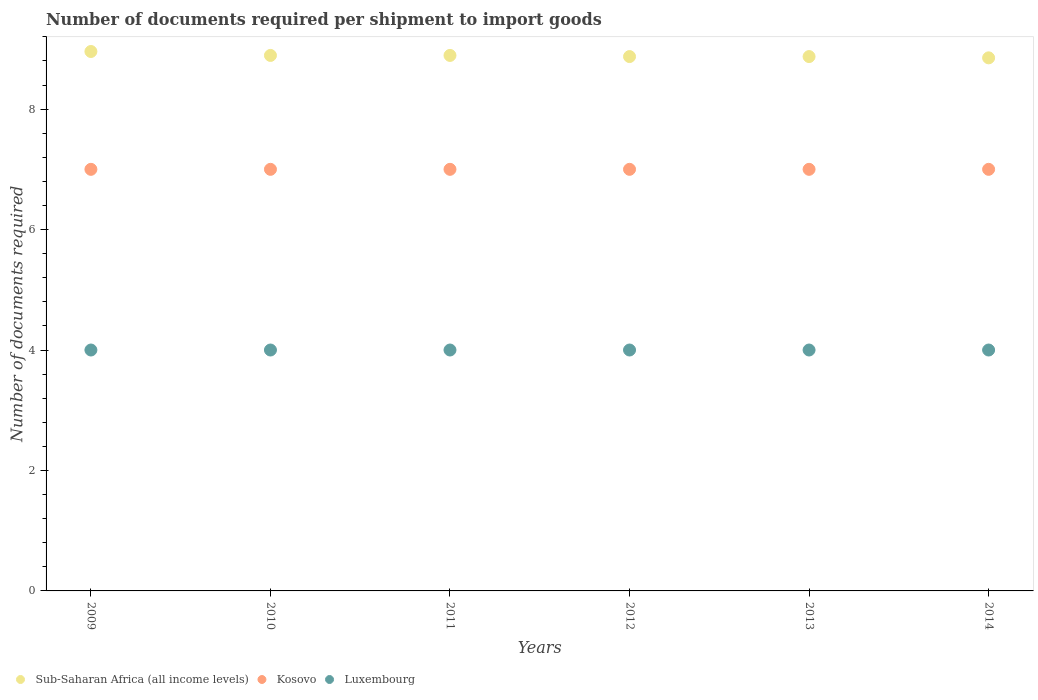How many different coloured dotlines are there?
Your answer should be compact. 3. Across all years, what is the maximum number of documents required per shipment to import goods in Kosovo?
Offer a terse response. 7. Across all years, what is the minimum number of documents required per shipment to import goods in Sub-Saharan Africa (all income levels)?
Ensure brevity in your answer.  8.85. What is the total number of documents required per shipment to import goods in Sub-Saharan Africa (all income levels) in the graph?
Ensure brevity in your answer.  53.33. What is the difference between the number of documents required per shipment to import goods in Luxembourg in 2010 and the number of documents required per shipment to import goods in Kosovo in 2012?
Make the answer very short. -3. What is the average number of documents required per shipment to import goods in Luxembourg per year?
Provide a short and direct response. 4. In the year 2009, what is the difference between the number of documents required per shipment to import goods in Kosovo and number of documents required per shipment to import goods in Sub-Saharan Africa (all income levels)?
Your answer should be compact. -1.96. In how many years, is the number of documents required per shipment to import goods in Kosovo greater than 6.4?
Provide a short and direct response. 6. What is the ratio of the number of documents required per shipment to import goods in Luxembourg in 2013 to that in 2014?
Ensure brevity in your answer.  1. Is the number of documents required per shipment to import goods in Kosovo in 2010 less than that in 2014?
Your response must be concise. No. Is the number of documents required per shipment to import goods in Sub-Saharan Africa (all income levels) strictly less than the number of documents required per shipment to import goods in Kosovo over the years?
Give a very brief answer. No. What is the difference between two consecutive major ticks on the Y-axis?
Offer a very short reply. 2. Are the values on the major ticks of Y-axis written in scientific E-notation?
Keep it short and to the point. No. Does the graph contain grids?
Give a very brief answer. No. How are the legend labels stacked?
Keep it short and to the point. Horizontal. What is the title of the graph?
Your answer should be compact. Number of documents required per shipment to import goods. What is the label or title of the X-axis?
Provide a succinct answer. Years. What is the label or title of the Y-axis?
Provide a succinct answer. Number of documents required. What is the Number of documents required in Sub-Saharan Africa (all income levels) in 2009?
Ensure brevity in your answer.  8.96. What is the Number of documents required in Kosovo in 2009?
Offer a terse response. 7. What is the Number of documents required in Luxembourg in 2009?
Provide a short and direct response. 4. What is the Number of documents required of Sub-Saharan Africa (all income levels) in 2010?
Your response must be concise. 8.89. What is the Number of documents required of Kosovo in 2010?
Your response must be concise. 7. What is the Number of documents required in Luxembourg in 2010?
Your answer should be compact. 4. What is the Number of documents required of Sub-Saharan Africa (all income levels) in 2011?
Offer a terse response. 8.89. What is the Number of documents required of Luxembourg in 2011?
Your response must be concise. 4. What is the Number of documents required in Sub-Saharan Africa (all income levels) in 2012?
Offer a very short reply. 8.87. What is the Number of documents required of Kosovo in 2012?
Offer a very short reply. 7. What is the Number of documents required in Sub-Saharan Africa (all income levels) in 2013?
Your answer should be very brief. 8.87. What is the Number of documents required in Luxembourg in 2013?
Keep it short and to the point. 4. What is the Number of documents required in Sub-Saharan Africa (all income levels) in 2014?
Offer a terse response. 8.85. What is the Number of documents required in Luxembourg in 2014?
Your answer should be very brief. 4. Across all years, what is the maximum Number of documents required in Sub-Saharan Africa (all income levels)?
Ensure brevity in your answer.  8.96. Across all years, what is the maximum Number of documents required of Kosovo?
Give a very brief answer. 7. Across all years, what is the minimum Number of documents required of Sub-Saharan Africa (all income levels)?
Your answer should be very brief. 8.85. Across all years, what is the minimum Number of documents required in Luxembourg?
Give a very brief answer. 4. What is the total Number of documents required of Sub-Saharan Africa (all income levels) in the graph?
Keep it short and to the point. 53.33. What is the difference between the Number of documents required of Sub-Saharan Africa (all income levels) in 2009 and that in 2010?
Offer a very short reply. 0.07. What is the difference between the Number of documents required in Kosovo in 2009 and that in 2010?
Make the answer very short. 0. What is the difference between the Number of documents required of Sub-Saharan Africa (all income levels) in 2009 and that in 2011?
Your answer should be very brief. 0.07. What is the difference between the Number of documents required of Sub-Saharan Africa (all income levels) in 2009 and that in 2012?
Offer a very short reply. 0.08. What is the difference between the Number of documents required in Luxembourg in 2009 and that in 2012?
Offer a very short reply. 0. What is the difference between the Number of documents required in Sub-Saharan Africa (all income levels) in 2009 and that in 2013?
Offer a terse response. 0.08. What is the difference between the Number of documents required of Sub-Saharan Africa (all income levels) in 2009 and that in 2014?
Make the answer very short. 0.11. What is the difference between the Number of documents required in Luxembourg in 2009 and that in 2014?
Provide a short and direct response. 0. What is the difference between the Number of documents required of Sub-Saharan Africa (all income levels) in 2010 and that in 2011?
Your answer should be very brief. 0. What is the difference between the Number of documents required in Luxembourg in 2010 and that in 2011?
Your response must be concise. 0. What is the difference between the Number of documents required of Sub-Saharan Africa (all income levels) in 2010 and that in 2012?
Make the answer very short. 0.02. What is the difference between the Number of documents required in Kosovo in 2010 and that in 2012?
Your answer should be compact. 0. What is the difference between the Number of documents required of Luxembourg in 2010 and that in 2012?
Provide a short and direct response. 0. What is the difference between the Number of documents required of Sub-Saharan Africa (all income levels) in 2010 and that in 2013?
Offer a very short reply. 0.02. What is the difference between the Number of documents required of Luxembourg in 2010 and that in 2013?
Provide a succinct answer. 0. What is the difference between the Number of documents required of Sub-Saharan Africa (all income levels) in 2010 and that in 2014?
Offer a terse response. 0.04. What is the difference between the Number of documents required in Sub-Saharan Africa (all income levels) in 2011 and that in 2012?
Give a very brief answer. 0.02. What is the difference between the Number of documents required of Kosovo in 2011 and that in 2012?
Provide a short and direct response. 0. What is the difference between the Number of documents required of Luxembourg in 2011 and that in 2012?
Make the answer very short. 0. What is the difference between the Number of documents required of Sub-Saharan Africa (all income levels) in 2011 and that in 2013?
Your response must be concise. 0.02. What is the difference between the Number of documents required in Kosovo in 2011 and that in 2013?
Offer a terse response. 0. What is the difference between the Number of documents required of Luxembourg in 2011 and that in 2013?
Keep it short and to the point. 0. What is the difference between the Number of documents required in Sub-Saharan Africa (all income levels) in 2011 and that in 2014?
Your response must be concise. 0.04. What is the difference between the Number of documents required of Kosovo in 2011 and that in 2014?
Offer a very short reply. 0. What is the difference between the Number of documents required of Kosovo in 2012 and that in 2013?
Keep it short and to the point. 0. What is the difference between the Number of documents required in Sub-Saharan Africa (all income levels) in 2012 and that in 2014?
Provide a short and direct response. 0.02. What is the difference between the Number of documents required of Luxembourg in 2012 and that in 2014?
Give a very brief answer. 0. What is the difference between the Number of documents required of Sub-Saharan Africa (all income levels) in 2013 and that in 2014?
Provide a short and direct response. 0.02. What is the difference between the Number of documents required in Luxembourg in 2013 and that in 2014?
Provide a succinct answer. 0. What is the difference between the Number of documents required of Sub-Saharan Africa (all income levels) in 2009 and the Number of documents required of Kosovo in 2010?
Give a very brief answer. 1.96. What is the difference between the Number of documents required of Sub-Saharan Africa (all income levels) in 2009 and the Number of documents required of Luxembourg in 2010?
Your answer should be very brief. 4.96. What is the difference between the Number of documents required of Kosovo in 2009 and the Number of documents required of Luxembourg in 2010?
Give a very brief answer. 3. What is the difference between the Number of documents required of Sub-Saharan Africa (all income levels) in 2009 and the Number of documents required of Kosovo in 2011?
Your response must be concise. 1.96. What is the difference between the Number of documents required of Sub-Saharan Africa (all income levels) in 2009 and the Number of documents required of Luxembourg in 2011?
Offer a terse response. 4.96. What is the difference between the Number of documents required of Sub-Saharan Africa (all income levels) in 2009 and the Number of documents required of Kosovo in 2012?
Your answer should be very brief. 1.96. What is the difference between the Number of documents required of Sub-Saharan Africa (all income levels) in 2009 and the Number of documents required of Luxembourg in 2012?
Provide a short and direct response. 4.96. What is the difference between the Number of documents required in Sub-Saharan Africa (all income levels) in 2009 and the Number of documents required in Kosovo in 2013?
Offer a very short reply. 1.96. What is the difference between the Number of documents required in Sub-Saharan Africa (all income levels) in 2009 and the Number of documents required in Luxembourg in 2013?
Provide a short and direct response. 4.96. What is the difference between the Number of documents required in Kosovo in 2009 and the Number of documents required in Luxembourg in 2013?
Your answer should be compact. 3. What is the difference between the Number of documents required in Sub-Saharan Africa (all income levels) in 2009 and the Number of documents required in Kosovo in 2014?
Provide a short and direct response. 1.96. What is the difference between the Number of documents required of Sub-Saharan Africa (all income levels) in 2009 and the Number of documents required of Luxembourg in 2014?
Your response must be concise. 4.96. What is the difference between the Number of documents required of Sub-Saharan Africa (all income levels) in 2010 and the Number of documents required of Kosovo in 2011?
Offer a very short reply. 1.89. What is the difference between the Number of documents required of Sub-Saharan Africa (all income levels) in 2010 and the Number of documents required of Luxembourg in 2011?
Keep it short and to the point. 4.89. What is the difference between the Number of documents required of Kosovo in 2010 and the Number of documents required of Luxembourg in 2011?
Keep it short and to the point. 3. What is the difference between the Number of documents required in Sub-Saharan Africa (all income levels) in 2010 and the Number of documents required in Kosovo in 2012?
Provide a succinct answer. 1.89. What is the difference between the Number of documents required in Sub-Saharan Africa (all income levels) in 2010 and the Number of documents required in Luxembourg in 2012?
Your answer should be very brief. 4.89. What is the difference between the Number of documents required in Kosovo in 2010 and the Number of documents required in Luxembourg in 2012?
Your response must be concise. 3. What is the difference between the Number of documents required in Sub-Saharan Africa (all income levels) in 2010 and the Number of documents required in Kosovo in 2013?
Offer a terse response. 1.89. What is the difference between the Number of documents required of Sub-Saharan Africa (all income levels) in 2010 and the Number of documents required of Luxembourg in 2013?
Your answer should be compact. 4.89. What is the difference between the Number of documents required in Kosovo in 2010 and the Number of documents required in Luxembourg in 2013?
Provide a short and direct response. 3. What is the difference between the Number of documents required in Sub-Saharan Africa (all income levels) in 2010 and the Number of documents required in Kosovo in 2014?
Make the answer very short. 1.89. What is the difference between the Number of documents required in Sub-Saharan Africa (all income levels) in 2010 and the Number of documents required in Luxembourg in 2014?
Offer a terse response. 4.89. What is the difference between the Number of documents required of Kosovo in 2010 and the Number of documents required of Luxembourg in 2014?
Keep it short and to the point. 3. What is the difference between the Number of documents required in Sub-Saharan Africa (all income levels) in 2011 and the Number of documents required in Kosovo in 2012?
Give a very brief answer. 1.89. What is the difference between the Number of documents required of Sub-Saharan Africa (all income levels) in 2011 and the Number of documents required of Luxembourg in 2012?
Your answer should be compact. 4.89. What is the difference between the Number of documents required of Sub-Saharan Africa (all income levels) in 2011 and the Number of documents required of Kosovo in 2013?
Give a very brief answer. 1.89. What is the difference between the Number of documents required in Sub-Saharan Africa (all income levels) in 2011 and the Number of documents required in Luxembourg in 2013?
Your answer should be very brief. 4.89. What is the difference between the Number of documents required of Kosovo in 2011 and the Number of documents required of Luxembourg in 2013?
Make the answer very short. 3. What is the difference between the Number of documents required of Sub-Saharan Africa (all income levels) in 2011 and the Number of documents required of Kosovo in 2014?
Offer a terse response. 1.89. What is the difference between the Number of documents required in Sub-Saharan Africa (all income levels) in 2011 and the Number of documents required in Luxembourg in 2014?
Your response must be concise. 4.89. What is the difference between the Number of documents required in Kosovo in 2011 and the Number of documents required in Luxembourg in 2014?
Give a very brief answer. 3. What is the difference between the Number of documents required in Sub-Saharan Africa (all income levels) in 2012 and the Number of documents required in Kosovo in 2013?
Provide a succinct answer. 1.87. What is the difference between the Number of documents required in Sub-Saharan Africa (all income levels) in 2012 and the Number of documents required in Luxembourg in 2013?
Offer a very short reply. 4.87. What is the difference between the Number of documents required in Kosovo in 2012 and the Number of documents required in Luxembourg in 2013?
Ensure brevity in your answer.  3. What is the difference between the Number of documents required of Sub-Saharan Africa (all income levels) in 2012 and the Number of documents required of Kosovo in 2014?
Provide a short and direct response. 1.87. What is the difference between the Number of documents required of Sub-Saharan Africa (all income levels) in 2012 and the Number of documents required of Luxembourg in 2014?
Keep it short and to the point. 4.87. What is the difference between the Number of documents required in Sub-Saharan Africa (all income levels) in 2013 and the Number of documents required in Kosovo in 2014?
Provide a short and direct response. 1.87. What is the difference between the Number of documents required of Sub-Saharan Africa (all income levels) in 2013 and the Number of documents required of Luxembourg in 2014?
Give a very brief answer. 4.87. What is the difference between the Number of documents required of Kosovo in 2013 and the Number of documents required of Luxembourg in 2014?
Your answer should be compact. 3. What is the average Number of documents required of Sub-Saharan Africa (all income levels) per year?
Keep it short and to the point. 8.89. What is the average Number of documents required in Kosovo per year?
Keep it short and to the point. 7. What is the average Number of documents required in Luxembourg per year?
Give a very brief answer. 4. In the year 2009, what is the difference between the Number of documents required of Sub-Saharan Africa (all income levels) and Number of documents required of Kosovo?
Your answer should be compact. 1.96. In the year 2009, what is the difference between the Number of documents required of Sub-Saharan Africa (all income levels) and Number of documents required of Luxembourg?
Make the answer very short. 4.96. In the year 2009, what is the difference between the Number of documents required of Kosovo and Number of documents required of Luxembourg?
Your answer should be compact. 3. In the year 2010, what is the difference between the Number of documents required of Sub-Saharan Africa (all income levels) and Number of documents required of Kosovo?
Your answer should be very brief. 1.89. In the year 2010, what is the difference between the Number of documents required in Sub-Saharan Africa (all income levels) and Number of documents required in Luxembourg?
Offer a terse response. 4.89. In the year 2010, what is the difference between the Number of documents required in Kosovo and Number of documents required in Luxembourg?
Offer a very short reply. 3. In the year 2011, what is the difference between the Number of documents required in Sub-Saharan Africa (all income levels) and Number of documents required in Kosovo?
Give a very brief answer. 1.89. In the year 2011, what is the difference between the Number of documents required of Sub-Saharan Africa (all income levels) and Number of documents required of Luxembourg?
Keep it short and to the point. 4.89. In the year 2012, what is the difference between the Number of documents required in Sub-Saharan Africa (all income levels) and Number of documents required in Kosovo?
Provide a short and direct response. 1.87. In the year 2012, what is the difference between the Number of documents required in Sub-Saharan Africa (all income levels) and Number of documents required in Luxembourg?
Give a very brief answer. 4.87. In the year 2012, what is the difference between the Number of documents required of Kosovo and Number of documents required of Luxembourg?
Ensure brevity in your answer.  3. In the year 2013, what is the difference between the Number of documents required of Sub-Saharan Africa (all income levels) and Number of documents required of Kosovo?
Provide a short and direct response. 1.87. In the year 2013, what is the difference between the Number of documents required in Sub-Saharan Africa (all income levels) and Number of documents required in Luxembourg?
Provide a short and direct response. 4.87. In the year 2013, what is the difference between the Number of documents required of Kosovo and Number of documents required of Luxembourg?
Provide a short and direct response. 3. In the year 2014, what is the difference between the Number of documents required in Sub-Saharan Africa (all income levels) and Number of documents required in Kosovo?
Give a very brief answer. 1.85. In the year 2014, what is the difference between the Number of documents required in Sub-Saharan Africa (all income levels) and Number of documents required in Luxembourg?
Provide a short and direct response. 4.85. What is the ratio of the Number of documents required of Sub-Saharan Africa (all income levels) in 2009 to that in 2010?
Make the answer very short. 1.01. What is the ratio of the Number of documents required of Sub-Saharan Africa (all income levels) in 2009 to that in 2011?
Make the answer very short. 1.01. What is the ratio of the Number of documents required of Sub-Saharan Africa (all income levels) in 2009 to that in 2012?
Offer a terse response. 1.01. What is the ratio of the Number of documents required in Sub-Saharan Africa (all income levels) in 2009 to that in 2013?
Your response must be concise. 1.01. What is the ratio of the Number of documents required in Kosovo in 2009 to that in 2013?
Provide a succinct answer. 1. What is the ratio of the Number of documents required in Luxembourg in 2009 to that in 2013?
Your answer should be compact. 1. What is the ratio of the Number of documents required in Sub-Saharan Africa (all income levels) in 2009 to that in 2014?
Your response must be concise. 1.01. What is the ratio of the Number of documents required in Kosovo in 2009 to that in 2014?
Provide a succinct answer. 1. What is the ratio of the Number of documents required of Luxembourg in 2009 to that in 2014?
Provide a short and direct response. 1. What is the ratio of the Number of documents required of Kosovo in 2010 to that in 2011?
Your answer should be very brief. 1. What is the ratio of the Number of documents required in Luxembourg in 2010 to that in 2011?
Provide a succinct answer. 1. What is the ratio of the Number of documents required in Luxembourg in 2010 to that in 2012?
Ensure brevity in your answer.  1. What is the ratio of the Number of documents required in Kosovo in 2010 to that in 2013?
Offer a terse response. 1. What is the ratio of the Number of documents required of Luxembourg in 2010 to that in 2014?
Make the answer very short. 1. What is the ratio of the Number of documents required of Sub-Saharan Africa (all income levels) in 2011 to that in 2012?
Make the answer very short. 1. What is the ratio of the Number of documents required in Kosovo in 2011 to that in 2012?
Offer a terse response. 1. What is the ratio of the Number of documents required of Luxembourg in 2011 to that in 2012?
Give a very brief answer. 1. What is the ratio of the Number of documents required of Sub-Saharan Africa (all income levels) in 2011 to that in 2013?
Keep it short and to the point. 1. What is the ratio of the Number of documents required of Luxembourg in 2011 to that in 2014?
Your answer should be very brief. 1. What is the ratio of the Number of documents required of Sub-Saharan Africa (all income levels) in 2012 to that in 2013?
Offer a very short reply. 1. What is the ratio of the Number of documents required in Sub-Saharan Africa (all income levels) in 2012 to that in 2014?
Your response must be concise. 1. What is the ratio of the Number of documents required of Kosovo in 2013 to that in 2014?
Your response must be concise. 1. What is the ratio of the Number of documents required of Luxembourg in 2013 to that in 2014?
Keep it short and to the point. 1. What is the difference between the highest and the second highest Number of documents required in Sub-Saharan Africa (all income levels)?
Offer a terse response. 0.07. What is the difference between the highest and the lowest Number of documents required in Sub-Saharan Africa (all income levels)?
Your answer should be compact. 0.11. What is the difference between the highest and the lowest Number of documents required of Kosovo?
Give a very brief answer. 0. 